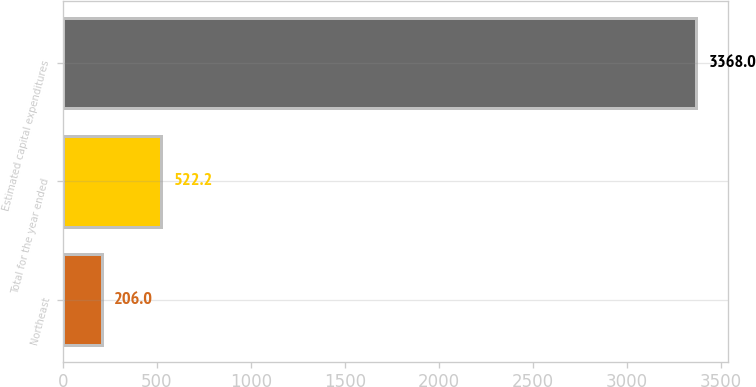<chart> <loc_0><loc_0><loc_500><loc_500><bar_chart><fcel>Northeast<fcel>Total for the year ended<fcel>Estimated capital expenditures<nl><fcel>206<fcel>522.2<fcel>3368<nl></chart> 